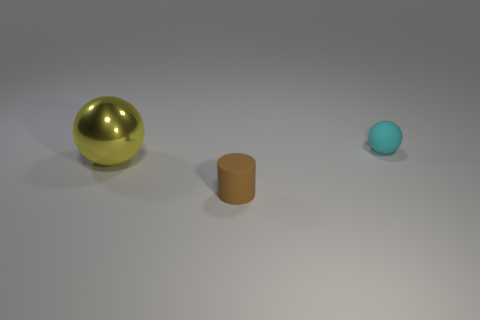Add 3 tiny green cubes. How many objects exist? 6 Subtract all yellow spheres. How many spheres are left? 1 Subtract all cylinders. How many objects are left? 2 Subtract 1 cyan spheres. How many objects are left? 2 Subtract 1 balls. How many balls are left? 1 Subtract all green spheres. Subtract all blue blocks. How many spheres are left? 2 Subtract all brown cylinders. How many cyan spheres are left? 1 Subtract all brown matte things. Subtract all large yellow shiny objects. How many objects are left? 1 Add 3 tiny matte objects. How many tiny matte objects are left? 5 Add 3 tiny red matte things. How many tiny red matte things exist? 3 